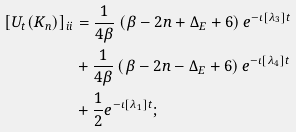<formula> <loc_0><loc_0><loc_500><loc_500>[ U _ { t } ( K _ { n } ) ] _ { i i } & = \frac { 1 } { 4 \beta } \left ( \beta - 2 n + \Delta _ { E } + 6 \right ) e ^ { - \iota \left [ \lambda _ { 3 } \right ] t } \\ & + \frac { 1 } { 4 \beta } \left ( \beta - 2 n - \Delta _ { E } + 6 \right ) e ^ { - \iota \left [ \lambda _ { 4 } \right ] t } \\ & + \frac { 1 } { 2 } e ^ { - \iota \left [ \lambda _ { 1 } \right ] t } ;</formula> 